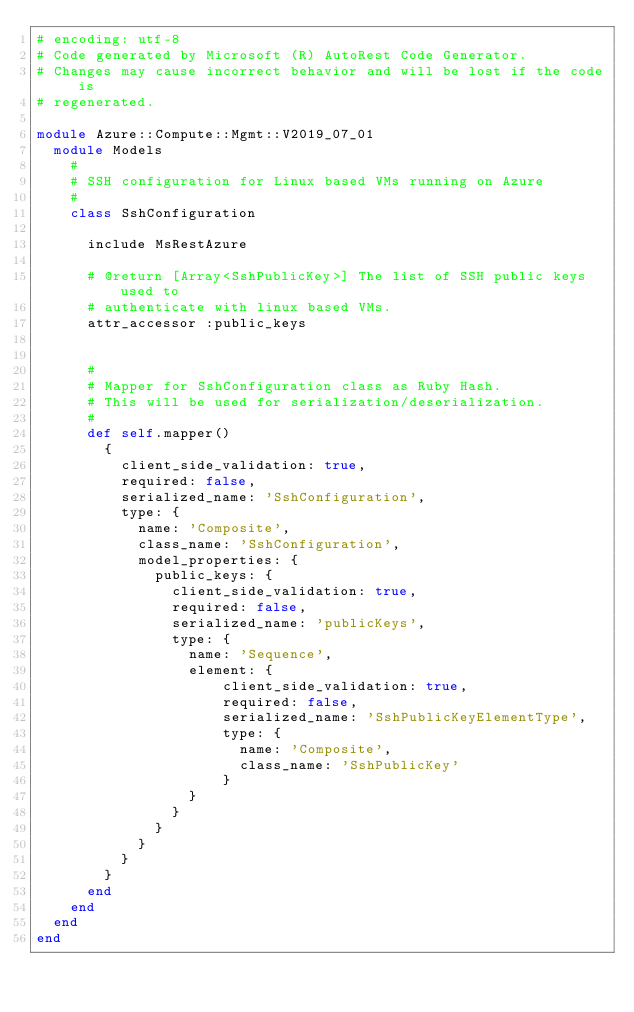Convert code to text. <code><loc_0><loc_0><loc_500><loc_500><_Ruby_># encoding: utf-8
# Code generated by Microsoft (R) AutoRest Code Generator.
# Changes may cause incorrect behavior and will be lost if the code is
# regenerated.

module Azure::Compute::Mgmt::V2019_07_01
  module Models
    #
    # SSH configuration for Linux based VMs running on Azure
    #
    class SshConfiguration

      include MsRestAzure

      # @return [Array<SshPublicKey>] The list of SSH public keys used to
      # authenticate with linux based VMs.
      attr_accessor :public_keys


      #
      # Mapper for SshConfiguration class as Ruby Hash.
      # This will be used for serialization/deserialization.
      #
      def self.mapper()
        {
          client_side_validation: true,
          required: false,
          serialized_name: 'SshConfiguration',
          type: {
            name: 'Composite',
            class_name: 'SshConfiguration',
            model_properties: {
              public_keys: {
                client_side_validation: true,
                required: false,
                serialized_name: 'publicKeys',
                type: {
                  name: 'Sequence',
                  element: {
                      client_side_validation: true,
                      required: false,
                      serialized_name: 'SshPublicKeyElementType',
                      type: {
                        name: 'Composite',
                        class_name: 'SshPublicKey'
                      }
                  }
                }
              }
            }
          }
        }
      end
    end
  end
end
</code> 